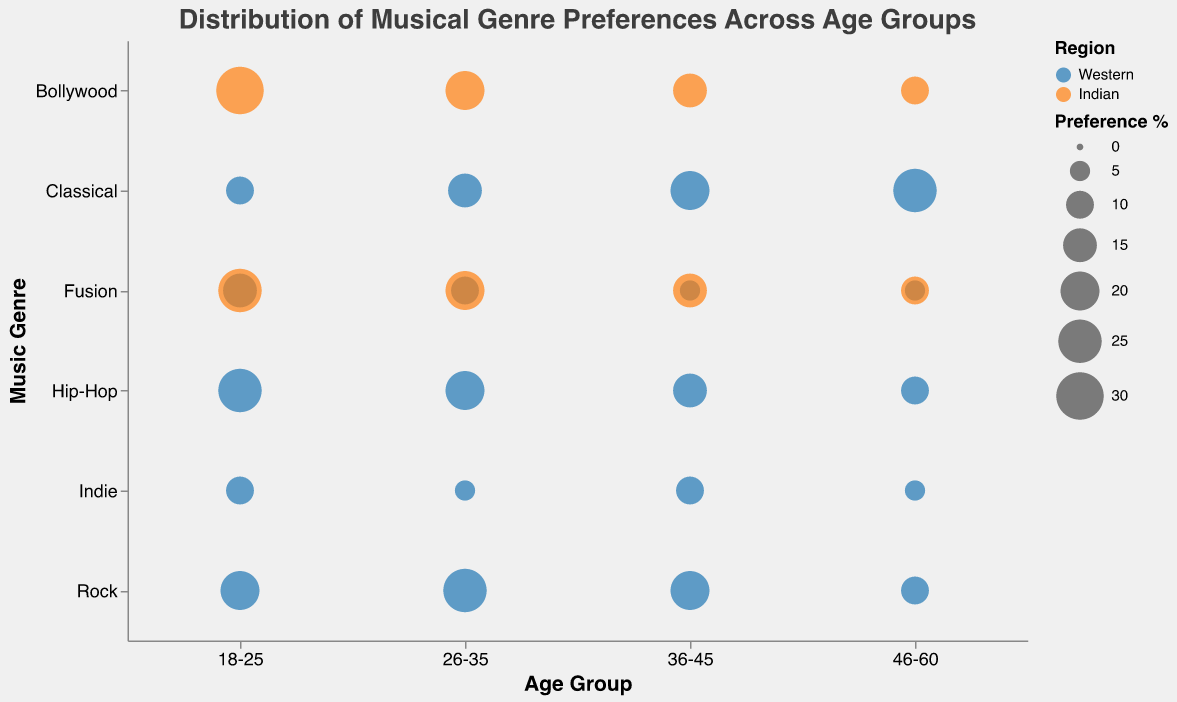What is the title of the bubble chart? The title of the bubble chart is prominently displayed at the top of the figure. It reads: "Distribution of Musical Genre Preferences Across Age Groups".
Answer: Distribution of Musical Genre Preferences Across Age Groups Which age group and musical genre has the highest preference percentage in the Indian region? Looking at the bubble sizes and noting the color representing the Indian region, the largest transparent bubble is in the 18-25 age group for Bollywood music. The size represents a 30% preference.
Answer: 18-25 age group for Bollywood In which age group do Fusion and Hip-Hop have equal preference percentages in the Western region? Observing the bubbles representing Fusion and Hip-Hop in the Western region, both genres have bubbles of the same size (5%) in the 46-60 age group.
Answer: 46-60 Which musical genre has the highest preference percentage in the 26-35 age group in the Western region? By comparing the bubble sizes for different genres in the 26-35 age group for the Western region, the largest bubble represents Rock with a 25% preference.
Answer: Rock How does the preference for Classical music change across age groups in the Western region? Starting with the 18-25 age group, the preference percentage for Classical music increases from 10% to 15% in 26-35, then to 20% in 36-45, and finally reaches 25% in 46-60.
Answer: Increases with age Compare the preference for Indie music between the Western and Indian regions across age groups. Indie music only appears in the Western region across all age groups. The percentages are 10%, 5%, 10%, and 5% for age groups 18-25, 26-35, 36-45, and 46-60 respectively. There are no bubbles for Indie in the Indian region.
Answer: Exclusive to Western region, varying percentages What is the sum of the preference percentages for Fusion across all age groups in the Indian region? Summing the percentages for Fusion in the Indian region across all age groups: 25% (18-25) + 20% (26-35) + 15% (36-45) + 10% (46-60) equals 70%.
Answer: 70% Which age group has the lowest overall preference for Fusion in both the Western and Indian regions combined? Adding up the Fusion preferences for each age group: 
18-25 (15% Western + 25% Indian) = 40%, 
26-35 (10% Western + 20% Indian) = 30%, 
36-45 (5% Western + 15% Indian) = 20%, 
46-60 (5% Western + 10% Indian) = 15%. 
The age group 46-60 has the lowest combined preference.
Answer: 46-60 